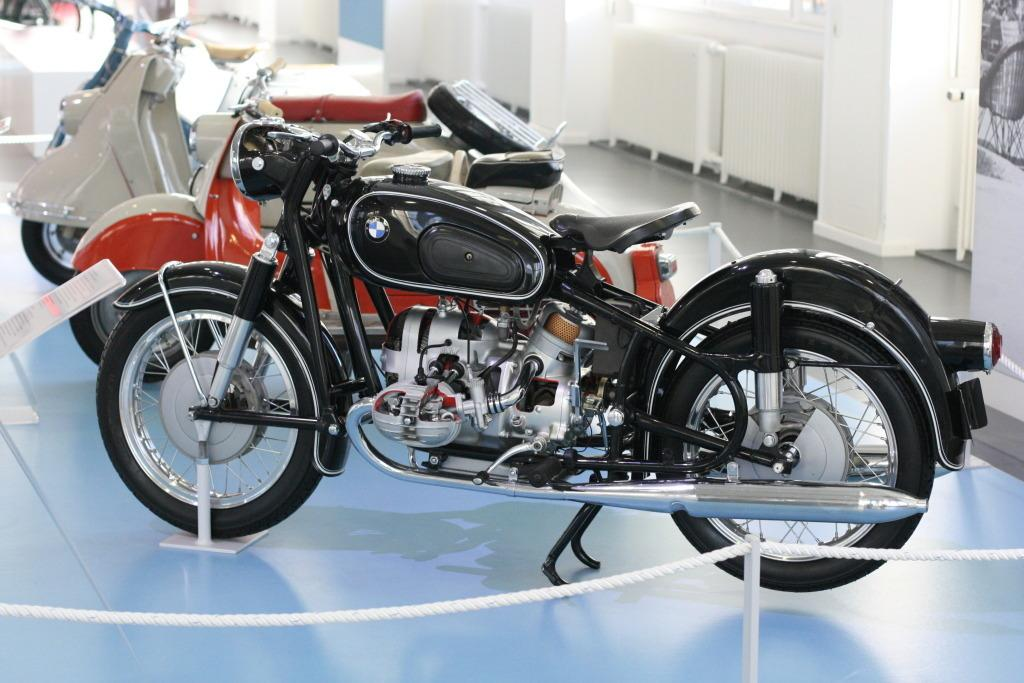What can be seen on the path in the image? There are vehicles on the path in the image. What is in front of the vehicles? There is a board and poles with a rope in front of the vehicles. What is behind the vehicles? There is a wall behind the vehicles. How many knees are visible in the image? There are no knees visible in the image. Can you see a kitten playing with the vehicles in the image? There is no kitten present in the image. 